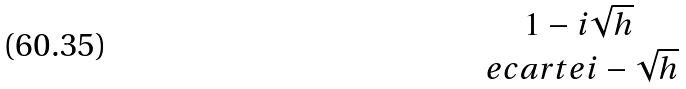<formula> <loc_0><loc_0><loc_500><loc_500>\begin{matrix} { 1 - i \sqrt { h } } \\ \ e c a r t e { i - \sqrt { h } } \end{matrix}</formula> 